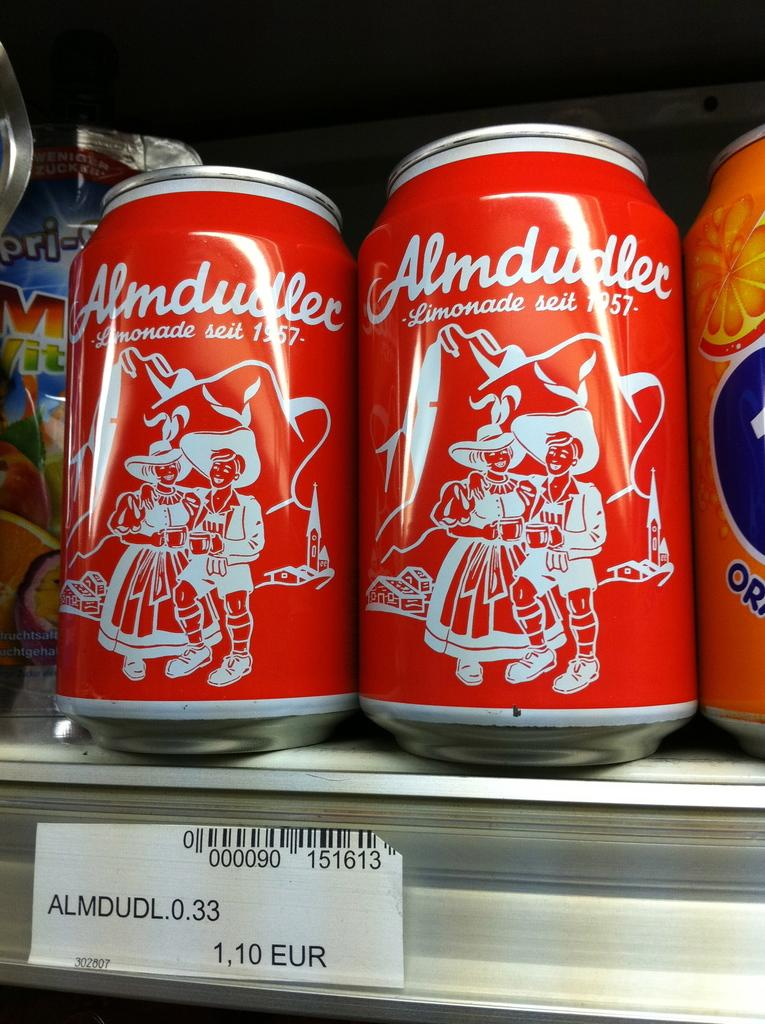<image>
Provide a brief description of the given image. Two red cans of Almdudler Limonade on a shelf in a retail store. 